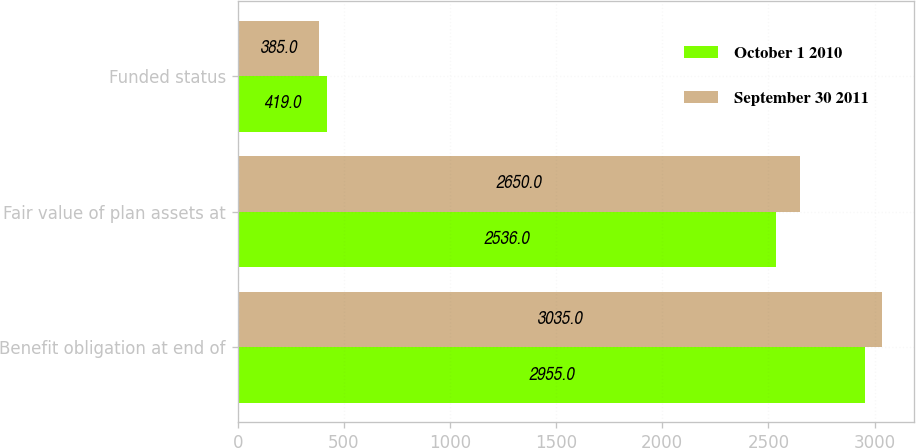Convert chart. <chart><loc_0><loc_0><loc_500><loc_500><stacked_bar_chart><ecel><fcel>Benefit obligation at end of<fcel>Fair value of plan assets at<fcel>Funded status<nl><fcel>October 1 2010<fcel>2955<fcel>2536<fcel>419<nl><fcel>September 30 2011<fcel>3035<fcel>2650<fcel>385<nl></chart> 